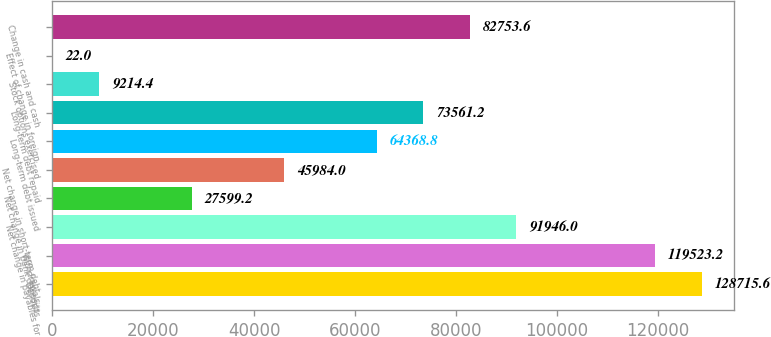Convert chart to OTSL. <chart><loc_0><loc_0><loc_500><loc_500><bar_chart><fcel>Deposits<fcel>Withdrawals<fcel>Net change in payables for<fcel>Net change in bank deposits<fcel>Net change in short-term debt<fcel>Long-term debt issued<fcel>Long-term debt repaid<fcel>Stock options exercised<fcel>Effect of change in foreign<fcel>Change in cash and cash<nl><fcel>128716<fcel>119523<fcel>91946<fcel>27599.2<fcel>45984<fcel>64368.8<fcel>73561.2<fcel>9214.4<fcel>22<fcel>82753.6<nl></chart> 